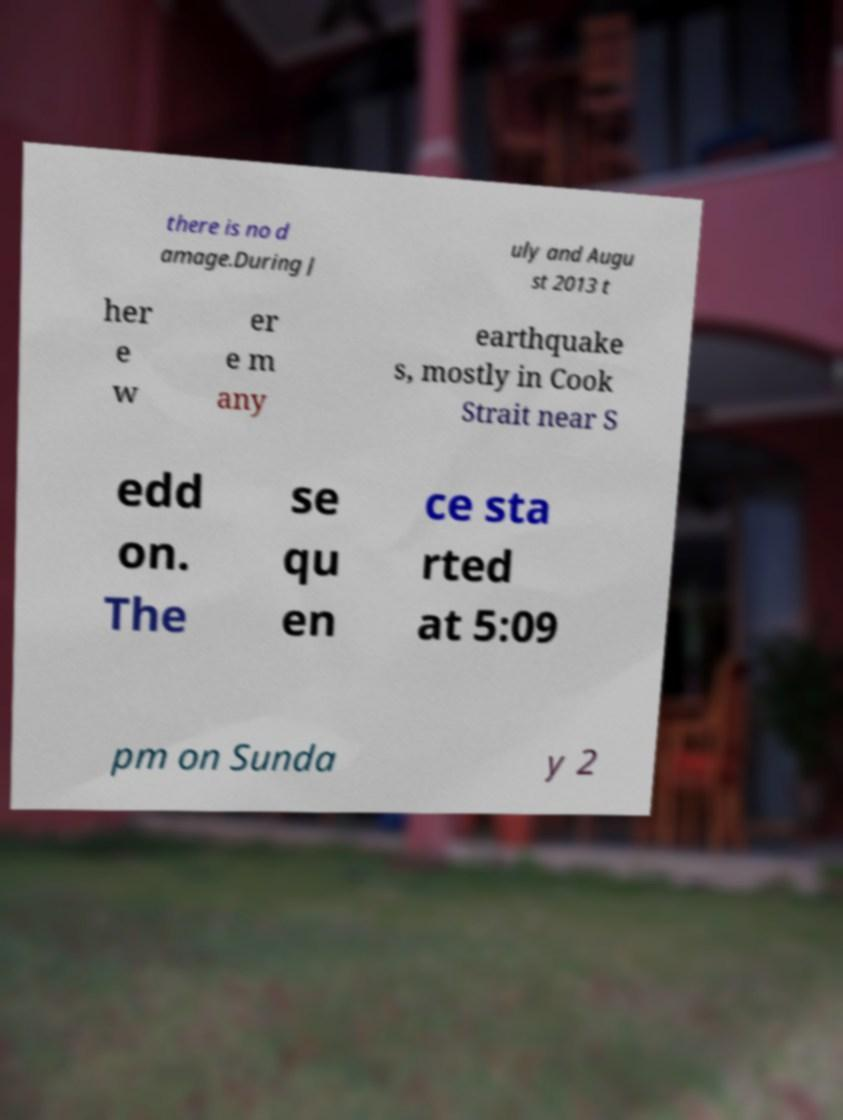Can you accurately transcribe the text from the provided image for me? there is no d amage.During J uly and Augu st 2013 t her e w er e m any earthquake s, mostly in Cook Strait near S edd on. The se qu en ce sta rted at 5:09 pm on Sunda y 2 